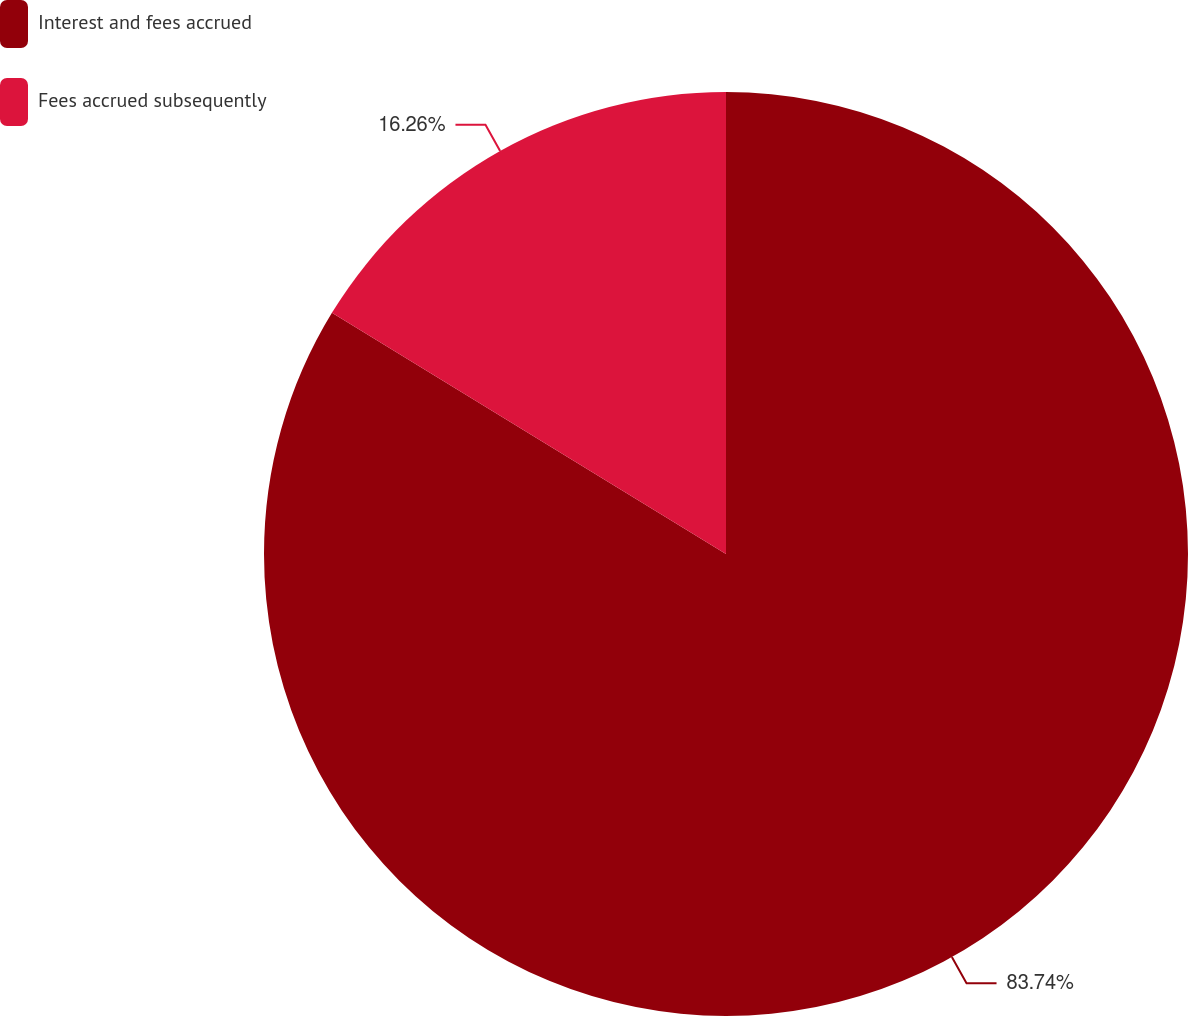<chart> <loc_0><loc_0><loc_500><loc_500><pie_chart><fcel>Interest and fees accrued<fcel>Fees accrued subsequently<nl><fcel>83.74%<fcel>16.26%<nl></chart> 